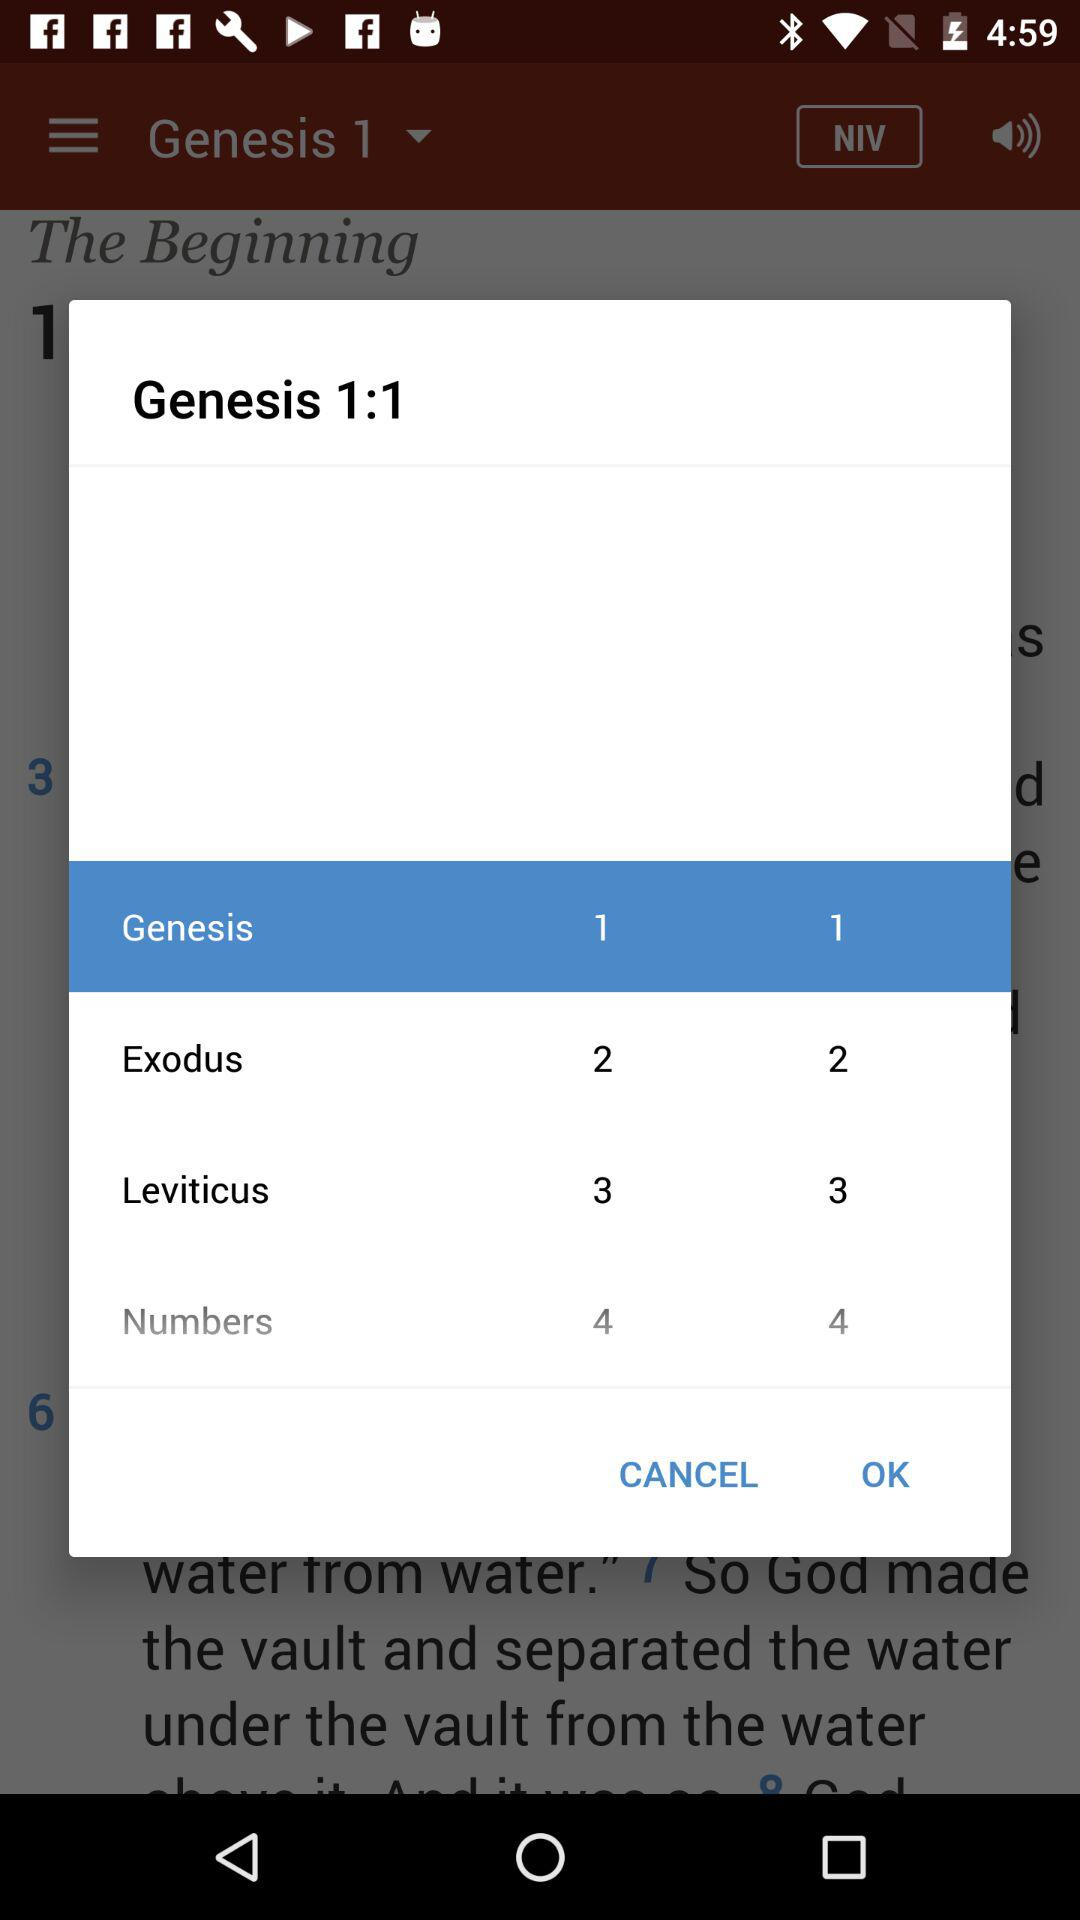What is the ratio of Exodus?
When the provided information is insufficient, respond with <no answer>. <no answer> 